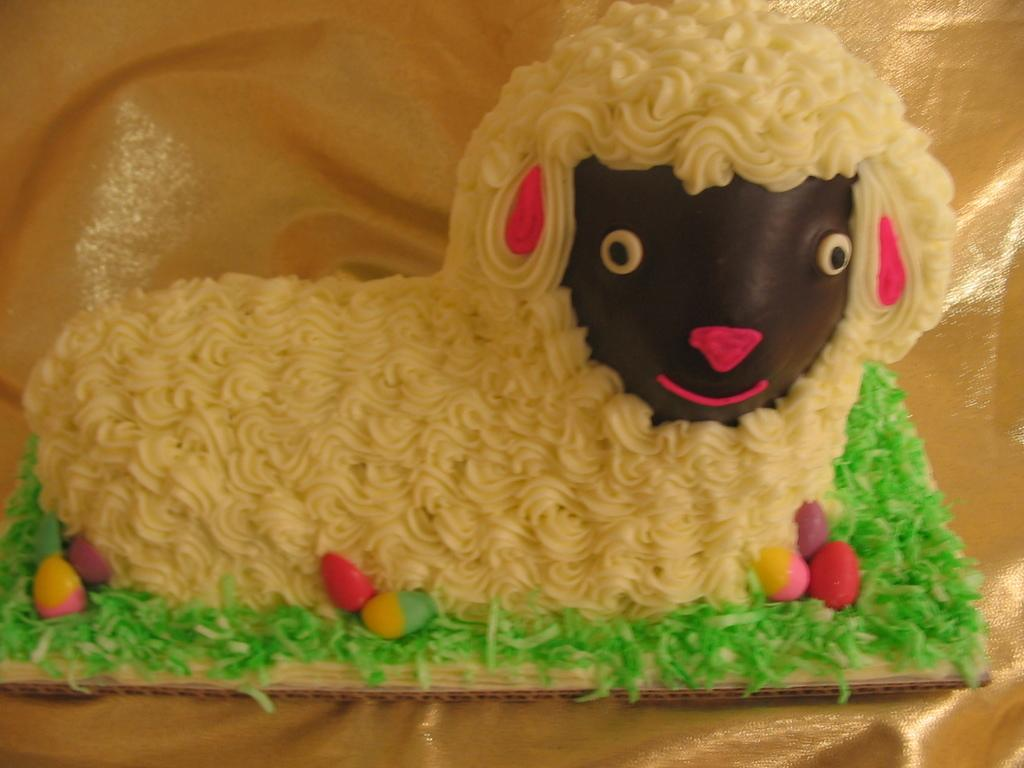What is the main subject of the image? The main subject of the image is a cake. What type of toothbrush is used to decorate the cake in the image? There is no toothbrush present in the image, and therefore no such decoration can be observed. 